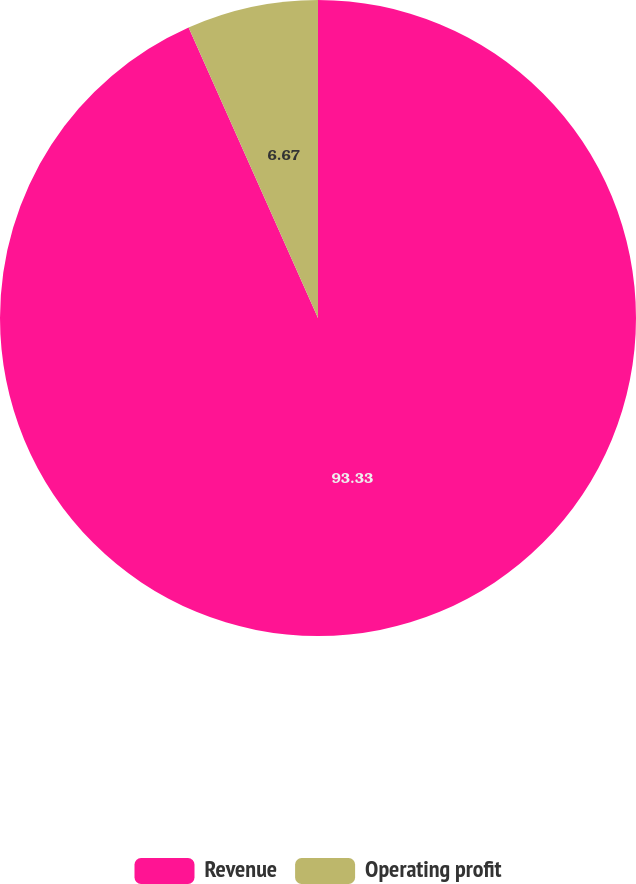Convert chart to OTSL. <chart><loc_0><loc_0><loc_500><loc_500><pie_chart><fcel>Revenue<fcel>Operating profit<nl><fcel>93.33%<fcel>6.67%<nl></chart> 